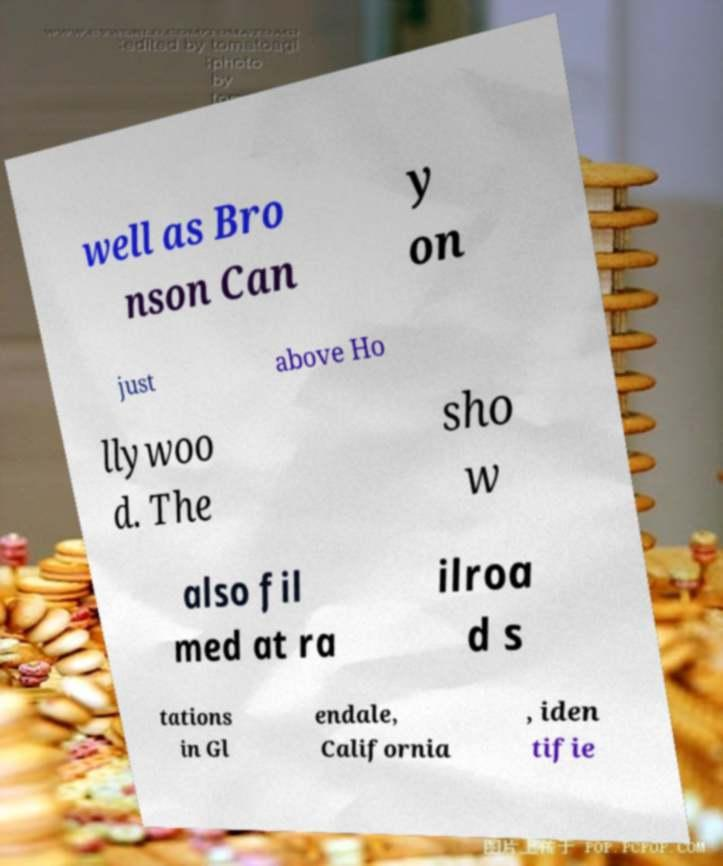Can you read and provide the text displayed in the image?This photo seems to have some interesting text. Can you extract and type it out for me? well as Bro nson Can y on just above Ho llywoo d. The sho w also fil med at ra ilroa d s tations in Gl endale, California , iden tifie 